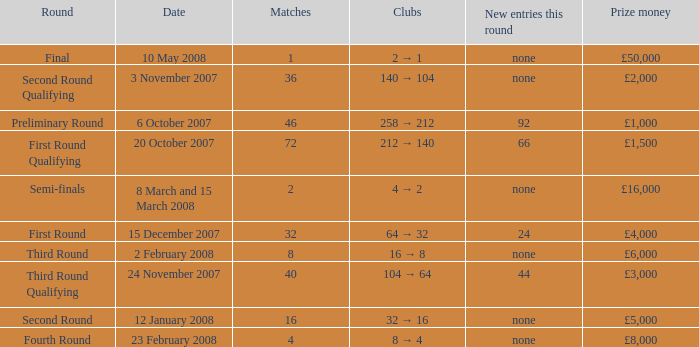What is the average for matches with a prize money amount of £3,000? 40.0. 